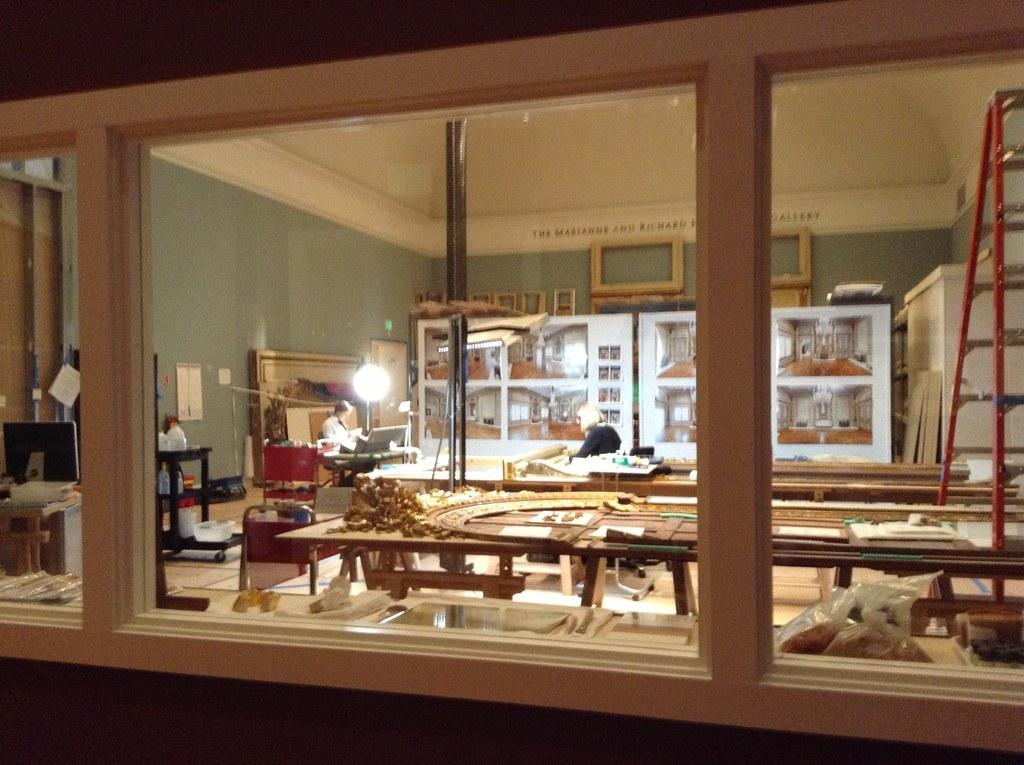What can be seen in the foreground of the image? There are windows and a dining table in the foreground area of the image. What is the purpose of the windows in the image? The windows provide natural light and a view of the surroundings. What can be seen in the background of the image? Showcases, cupboards, people, and other objects are present in the background. What type of objects are visible in the showcases? The specific objects in the showcases cannot be determined from the provided facts. What might the people in the background be doing? The people in the background might be interacting with the objects or engaging in activities, but their actions cannot be determined from the provided facts. What type of yarn is being used by the maid in the image? There is no maid or yarn present in the image. What type of work is being done by the people in the background? The specific work being done by the people in the background cannot be determined from the provided facts. 